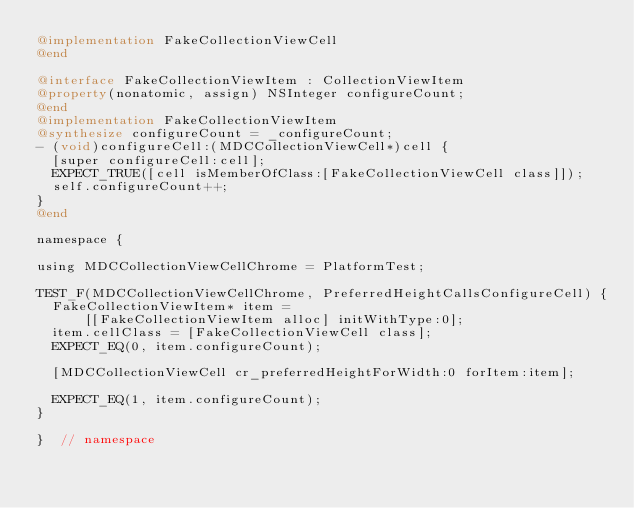<code> <loc_0><loc_0><loc_500><loc_500><_ObjectiveC_>@implementation FakeCollectionViewCell
@end

@interface FakeCollectionViewItem : CollectionViewItem
@property(nonatomic, assign) NSInteger configureCount;
@end
@implementation FakeCollectionViewItem
@synthesize configureCount = _configureCount;
- (void)configureCell:(MDCCollectionViewCell*)cell {
  [super configureCell:cell];
  EXPECT_TRUE([cell isMemberOfClass:[FakeCollectionViewCell class]]);
  self.configureCount++;
}
@end

namespace {

using MDCCollectionViewCellChrome = PlatformTest;

TEST_F(MDCCollectionViewCellChrome, PreferredHeightCallsConfigureCell) {
  FakeCollectionViewItem* item =
      [[FakeCollectionViewItem alloc] initWithType:0];
  item.cellClass = [FakeCollectionViewCell class];
  EXPECT_EQ(0, item.configureCount);

  [MDCCollectionViewCell cr_preferredHeightForWidth:0 forItem:item];

  EXPECT_EQ(1, item.configureCount);
}

}  // namespace
</code> 